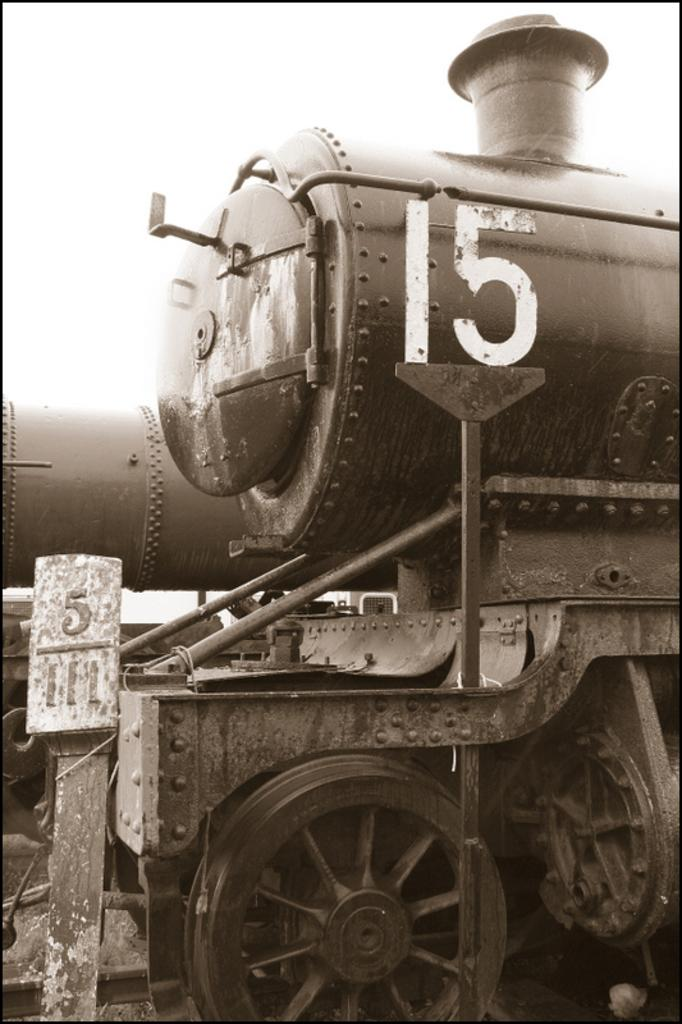What is the main subject of the picture? The main subject of the picture is a rail engine. What can be observed coming out of the rail engine? The rail engine has smoke exhaust. What are the wheels on the rail engine used for? The wheels on the rail engine are used for movement along the tracks. What information is displayed on the board near the rail engine? There is a board with a number 5/111 near the rail engine. Can you see any ghosts interacting with the rail engine in the image? A: There are no ghosts present in the image. What act is the rail engine performing in the image? The rail engine is not performing an act; it is simply a stationary object in the image. 